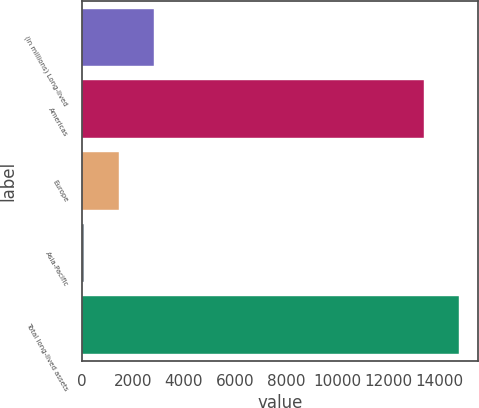<chart> <loc_0><loc_0><loc_500><loc_500><bar_chart><fcel>(in millions) Long-lived<fcel>Americas<fcel>Europe<fcel>Asia-Pacific<fcel>Total long-lived assets<nl><fcel>2817.6<fcel>13422<fcel>1456.8<fcel>96<fcel>14782.8<nl></chart> 